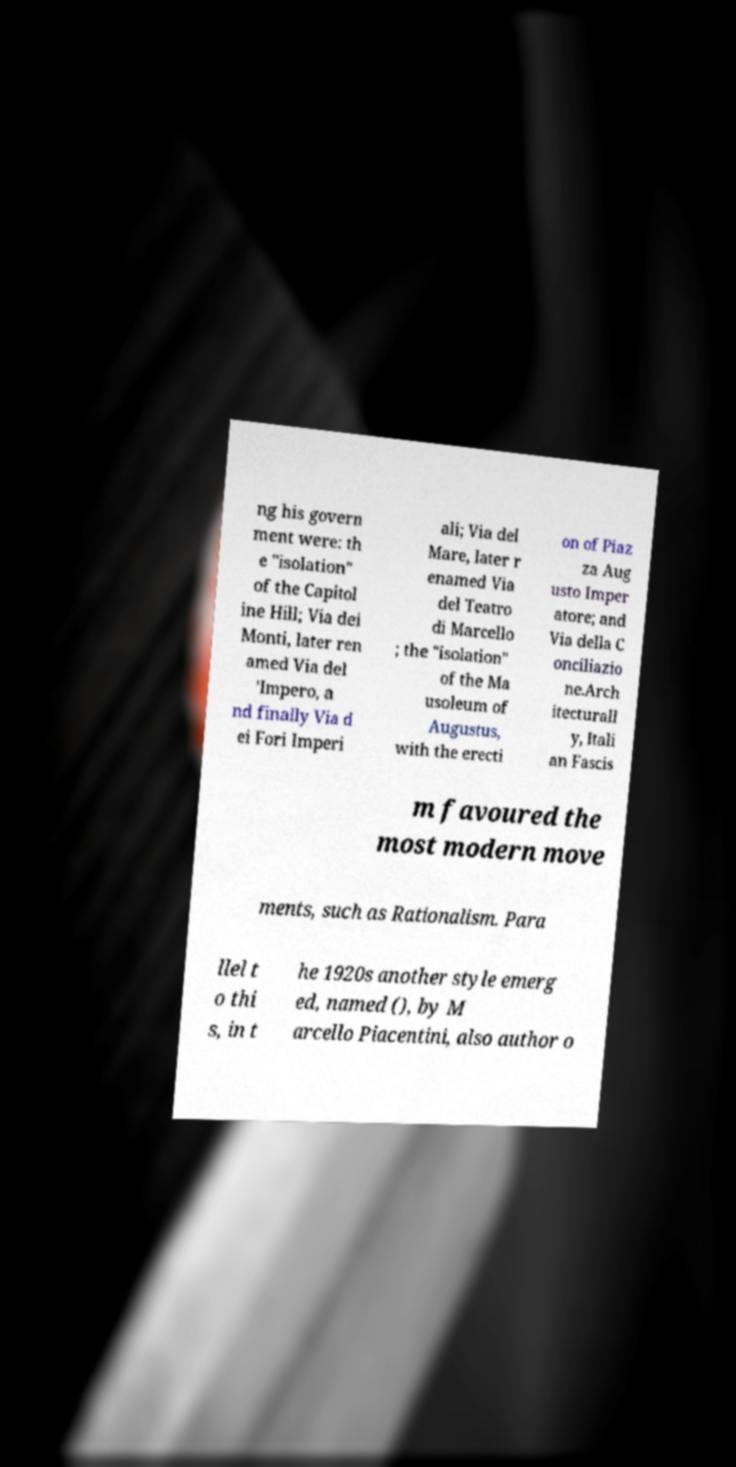I need the written content from this picture converted into text. Can you do that? ng his govern ment were: th e "isolation" of the Capitol ine Hill; Via dei Monti, later ren amed Via del 'Impero, a nd finally Via d ei Fori Imperi ali; Via del Mare, later r enamed Via del Teatro di Marcello ; the "isolation" of the Ma usoleum of Augustus, with the erecti on of Piaz za Aug usto Imper atore; and Via della C onciliazio ne.Arch itecturall y, Itali an Fascis m favoured the most modern move ments, such as Rationalism. Para llel t o thi s, in t he 1920s another style emerg ed, named (), by M arcello Piacentini, also author o 